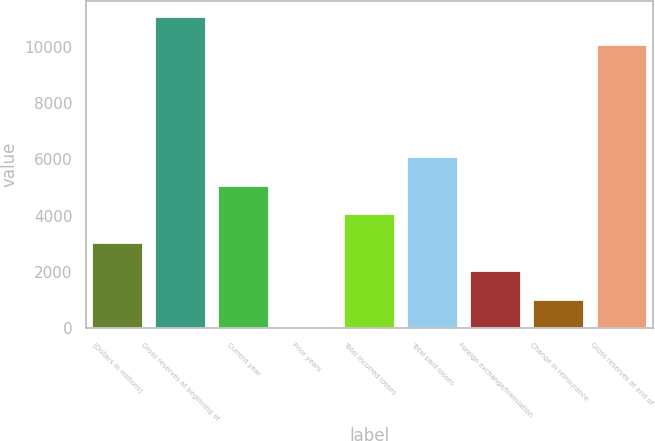Convert chart to OTSL. <chart><loc_0><loc_0><loc_500><loc_500><bar_chart><fcel>(Dollars in millions)<fcel>Gross reserves at beginning of<fcel>Current year<fcel>Prior years<fcel>Total incurred losses<fcel>Total paid losses<fcel>Foreign exchange/translation<fcel>Change in reinsurance<fcel>Gross reserves at end of<nl><fcel>3039.55<fcel>11081<fcel>5063.45<fcel>3.7<fcel>4051.5<fcel>6075.4<fcel>2027.6<fcel>1015.65<fcel>10069.1<nl></chart> 